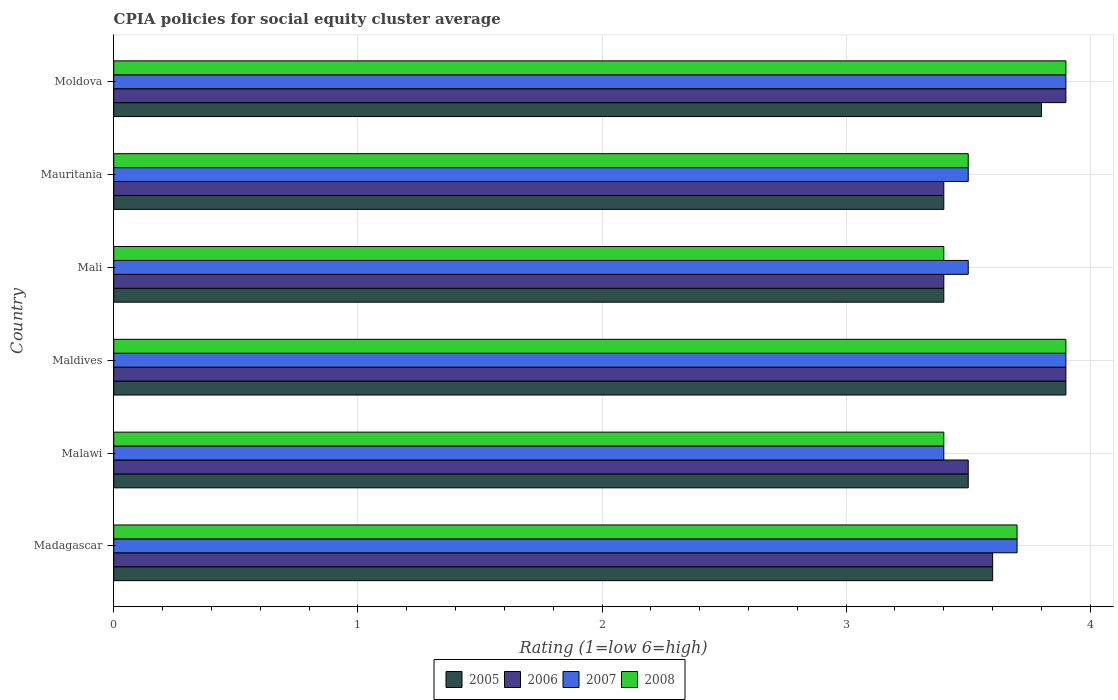How many different coloured bars are there?
Offer a terse response. 4. How many groups of bars are there?
Provide a succinct answer. 6. Are the number of bars on each tick of the Y-axis equal?
Give a very brief answer. Yes. How many bars are there on the 4th tick from the bottom?
Keep it short and to the point. 4. What is the label of the 2nd group of bars from the top?
Offer a terse response. Mauritania. Across all countries, what is the minimum CPIA rating in 2007?
Offer a terse response. 3.4. In which country was the CPIA rating in 2005 maximum?
Your answer should be compact. Maldives. In which country was the CPIA rating in 2006 minimum?
Give a very brief answer. Mali. What is the total CPIA rating in 2007 in the graph?
Provide a short and direct response. 21.9. What is the difference between the CPIA rating in 2008 in Madagascar and that in Mauritania?
Your response must be concise. 0.2. What is the difference between the CPIA rating in 2005 in Moldova and the CPIA rating in 2007 in Maldives?
Your response must be concise. -0.1. What is the average CPIA rating in 2008 per country?
Make the answer very short. 3.63. What is the difference between the CPIA rating in 2005 and CPIA rating in 2007 in Madagascar?
Your answer should be compact. -0.1. What is the ratio of the CPIA rating in 2008 in Madagascar to that in Mali?
Provide a succinct answer. 1.09. Is the difference between the CPIA rating in 2005 in Maldives and Mali greater than the difference between the CPIA rating in 2007 in Maldives and Mali?
Your answer should be compact. Yes. What is the difference between the highest and the second highest CPIA rating in 2008?
Your response must be concise. 0. In how many countries, is the CPIA rating in 2005 greater than the average CPIA rating in 2005 taken over all countries?
Offer a terse response. 2. Is the sum of the CPIA rating in 2005 in Madagascar and Maldives greater than the maximum CPIA rating in 2008 across all countries?
Your answer should be compact. Yes. What does the 1st bar from the bottom in Mali represents?
Provide a short and direct response. 2005. Is it the case that in every country, the sum of the CPIA rating in 2006 and CPIA rating in 2005 is greater than the CPIA rating in 2008?
Your answer should be very brief. Yes. How many bars are there?
Ensure brevity in your answer.  24. How many countries are there in the graph?
Make the answer very short. 6. Does the graph contain grids?
Ensure brevity in your answer.  Yes. How many legend labels are there?
Offer a very short reply. 4. How are the legend labels stacked?
Give a very brief answer. Horizontal. What is the title of the graph?
Ensure brevity in your answer.  CPIA policies for social equity cluster average. What is the Rating (1=low 6=high) of 2007 in Malawi?
Your response must be concise. 3.4. What is the Rating (1=low 6=high) in 2005 in Maldives?
Keep it short and to the point. 3.9. What is the Rating (1=low 6=high) of 2007 in Maldives?
Your answer should be very brief. 3.9. What is the Rating (1=low 6=high) of 2008 in Maldives?
Your response must be concise. 3.9. What is the Rating (1=low 6=high) of 2006 in Mali?
Your answer should be very brief. 3.4. What is the Rating (1=low 6=high) in 2005 in Mauritania?
Provide a succinct answer. 3.4. What is the Rating (1=low 6=high) in 2007 in Mauritania?
Offer a very short reply. 3.5. What is the Rating (1=low 6=high) in 2008 in Mauritania?
Your response must be concise. 3.5. What is the Rating (1=low 6=high) in 2006 in Moldova?
Provide a short and direct response. 3.9. What is the Rating (1=low 6=high) in 2007 in Moldova?
Offer a very short reply. 3.9. Across all countries, what is the maximum Rating (1=low 6=high) of 2007?
Your answer should be compact. 3.9. Across all countries, what is the minimum Rating (1=low 6=high) in 2007?
Make the answer very short. 3.4. Across all countries, what is the minimum Rating (1=low 6=high) of 2008?
Make the answer very short. 3.4. What is the total Rating (1=low 6=high) in 2005 in the graph?
Ensure brevity in your answer.  21.6. What is the total Rating (1=low 6=high) in 2006 in the graph?
Offer a very short reply. 21.7. What is the total Rating (1=low 6=high) of 2007 in the graph?
Your answer should be compact. 21.9. What is the total Rating (1=low 6=high) in 2008 in the graph?
Ensure brevity in your answer.  21.8. What is the difference between the Rating (1=low 6=high) of 2006 in Madagascar and that in Malawi?
Provide a succinct answer. 0.1. What is the difference between the Rating (1=low 6=high) of 2006 in Madagascar and that in Maldives?
Give a very brief answer. -0.3. What is the difference between the Rating (1=low 6=high) of 2007 in Madagascar and that in Maldives?
Provide a succinct answer. -0.2. What is the difference between the Rating (1=low 6=high) in 2005 in Madagascar and that in Mauritania?
Ensure brevity in your answer.  0.2. What is the difference between the Rating (1=low 6=high) in 2007 in Madagascar and that in Mauritania?
Your response must be concise. 0.2. What is the difference between the Rating (1=low 6=high) in 2005 in Madagascar and that in Moldova?
Give a very brief answer. -0.2. What is the difference between the Rating (1=low 6=high) in 2006 in Madagascar and that in Moldova?
Offer a terse response. -0.3. What is the difference between the Rating (1=low 6=high) of 2007 in Madagascar and that in Moldova?
Provide a short and direct response. -0.2. What is the difference between the Rating (1=low 6=high) of 2007 in Malawi and that in Maldives?
Offer a terse response. -0.5. What is the difference between the Rating (1=low 6=high) of 2008 in Malawi and that in Maldives?
Ensure brevity in your answer.  -0.5. What is the difference between the Rating (1=low 6=high) of 2006 in Malawi and that in Moldova?
Your answer should be compact. -0.4. What is the difference between the Rating (1=low 6=high) of 2006 in Maldives and that in Mali?
Provide a short and direct response. 0.5. What is the difference between the Rating (1=low 6=high) of 2005 in Maldives and that in Moldova?
Your answer should be very brief. 0.1. What is the difference between the Rating (1=low 6=high) of 2005 in Mali and that in Mauritania?
Ensure brevity in your answer.  0. What is the difference between the Rating (1=low 6=high) of 2006 in Mali and that in Mauritania?
Provide a short and direct response. 0. What is the difference between the Rating (1=low 6=high) of 2007 in Mali and that in Mauritania?
Give a very brief answer. 0. What is the difference between the Rating (1=low 6=high) of 2008 in Mali and that in Mauritania?
Your answer should be compact. -0.1. What is the difference between the Rating (1=low 6=high) in 2007 in Mali and that in Moldova?
Provide a succinct answer. -0.4. What is the difference between the Rating (1=low 6=high) in 2008 in Mali and that in Moldova?
Provide a succinct answer. -0.5. What is the difference between the Rating (1=low 6=high) in 2006 in Mauritania and that in Moldova?
Provide a short and direct response. -0.5. What is the difference between the Rating (1=low 6=high) of 2007 in Mauritania and that in Moldova?
Your response must be concise. -0.4. What is the difference between the Rating (1=low 6=high) in 2005 in Madagascar and the Rating (1=low 6=high) in 2006 in Malawi?
Offer a terse response. 0.1. What is the difference between the Rating (1=low 6=high) in 2005 in Madagascar and the Rating (1=low 6=high) in 2007 in Malawi?
Make the answer very short. 0.2. What is the difference between the Rating (1=low 6=high) of 2005 in Madagascar and the Rating (1=low 6=high) of 2008 in Malawi?
Give a very brief answer. 0.2. What is the difference between the Rating (1=low 6=high) of 2006 in Madagascar and the Rating (1=low 6=high) of 2007 in Malawi?
Provide a succinct answer. 0.2. What is the difference between the Rating (1=low 6=high) of 2007 in Madagascar and the Rating (1=low 6=high) of 2008 in Malawi?
Offer a very short reply. 0.3. What is the difference between the Rating (1=low 6=high) of 2005 in Madagascar and the Rating (1=low 6=high) of 2008 in Maldives?
Give a very brief answer. -0.3. What is the difference between the Rating (1=low 6=high) of 2006 in Madagascar and the Rating (1=low 6=high) of 2007 in Maldives?
Your answer should be compact. -0.3. What is the difference between the Rating (1=low 6=high) in 2005 in Madagascar and the Rating (1=low 6=high) in 2006 in Mali?
Your response must be concise. 0.2. What is the difference between the Rating (1=low 6=high) of 2005 in Madagascar and the Rating (1=low 6=high) of 2008 in Mali?
Your answer should be very brief. 0.2. What is the difference between the Rating (1=low 6=high) in 2006 in Madagascar and the Rating (1=low 6=high) in 2008 in Mali?
Offer a terse response. 0.2. What is the difference between the Rating (1=low 6=high) in 2006 in Madagascar and the Rating (1=low 6=high) in 2007 in Mauritania?
Provide a short and direct response. 0.1. What is the difference between the Rating (1=low 6=high) of 2006 in Madagascar and the Rating (1=low 6=high) of 2008 in Mauritania?
Your answer should be compact. 0.1. What is the difference between the Rating (1=low 6=high) of 2007 in Madagascar and the Rating (1=low 6=high) of 2008 in Mauritania?
Provide a short and direct response. 0.2. What is the difference between the Rating (1=low 6=high) of 2005 in Madagascar and the Rating (1=low 6=high) of 2007 in Moldova?
Keep it short and to the point. -0.3. What is the difference between the Rating (1=low 6=high) of 2006 in Madagascar and the Rating (1=low 6=high) of 2007 in Moldova?
Your answer should be very brief. -0.3. What is the difference between the Rating (1=low 6=high) in 2005 in Malawi and the Rating (1=low 6=high) in 2006 in Maldives?
Your response must be concise. -0.4. What is the difference between the Rating (1=low 6=high) of 2006 in Malawi and the Rating (1=low 6=high) of 2008 in Maldives?
Give a very brief answer. -0.4. What is the difference between the Rating (1=low 6=high) in 2005 in Malawi and the Rating (1=low 6=high) in 2007 in Mali?
Your response must be concise. 0. What is the difference between the Rating (1=low 6=high) of 2005 in Malawi and the Rating (1=low 6=high) of 2008 in Mali?
Keep it short and to the point. 0.1. What is the difference between the Rating (1=low 6=high) of 2006 in Malawi and the Rating (1=low 6=high) of 2008 in Mali?
Provide a short and direct response. 0.1. What is the difference between the Rating (1=low 6=high) in 2005 in Malawi and the Rating (1=low 6=high) in 2006 in Mauritania?
Ensure brevity in your answer.  0.1. What is the difference between the Rating (1=low 6=high) in 2005 in Malawi and the Rating (1=low 6=high) in 2007 in Mauritania?
Make the answer very short. 0. What is the difference between the Rating (1=low 6=high) in 2006 in Malawi and the Rating (1=low 6=high) in 2007 in Mauritania?
Your response must be concise. 0. What is the difference between the Rating (1=low 6=high) in 2005 in Malawi and the Rating (1=low 6=high) in 2007 in Moldova?
Your answer should be compact. -0.4. What is the difference between the Rating (1=low 6=high) of 2007 in Malawi and the Rating (1=low 6=high) of 2008 in Moldova?
Provide a short and direct response. -0.5. What is the difference between the Rating (1=low 6=high) in 2005 in Maldives and the Rating (1=low 6=high) in 2007 in Mali?
Your answer should be very brief. 0.4. What is the difference between the Rating (1=low 6=high) of 2005 in Maldives and the Rating (1=low 6=high) of 2008 in Mali?
Keep it short and to the point. 0.5. What is the difference between the Rating (1=low 6=high) of 2006 in Maldives and the Rating (1=low 6=high) of 2007 in Mali?
Provide a succinct answer. 0.4. What is the difference between the Rating (1=low 6=high) in 2006 in Maldives and the Rating (1=low 6=high) in 2008 in Mali?
Your answer should be very brief. 0.5. What is the difference between the Rating (1=low 6=high) in 2007 in Maldives and the Rating (1=low 6=high) in 2008 in Mali?
Provide a short and direct response. 0.5. What is the difference between the Rating (1=low 6=high) in 2005 in Maldives and the Rating (1=low 6=high) in 2006 in Moldova?
Offer a terse response. 0. What is the difference between the Rating (1=low 6=high) of 2006 in Maldives and the Rating (1=low 6=high) of 2007 in Moldova?
Your response must be concise. 0. What is the difference between the Rating (1=low 6=high) in 2007 in Maldives and the Rating (1=low 6=high) in 2008 in Moldova?
Your answer should be compact. 0. What is the difference between the Rating (1=low 6=high) in 2005 in Mali and the Rating (1=low 6=high) in 2006 in Mauritania?
Offer a terse response. 0. What is the difference between the Rating (1=low 6=high) in 2005 in Mali and the Rating (1=low 6=high) in 2007 in Mauritania?
Ensure brevity in your answer.  -0.1. What is the difference between the Rating (1=low 6=high) in 2006 in Mali and the Rating (1=low 6=high) in 2008 in Mauritania?
Offer a very short reply. -0.1. What is the difference between the Rating (1=low 6=high) of 2007 in Mali and the Rating (1=low 6=high) of 2008 in Mauritania?
Ensure brevity in your answer.  0. What is the difference between the Rating (1=low 6=high) of 2005 in Mali and the Rating (1=low 6=high) of 2006 in Moldova?
Offer a very short reply. -0.5. What is the difference between the Rating (1=low 6=high) in 2005 in Mali and the Rating (1=low 6=high) in 2008 in Moldova?
Keep it short and to the point. -0.5. What is the difference between the Rating (1=low 6=high) in 2006 in Mali and the Rating (1=low 6=high) in 2007 in Moldova?
Provide a succinct answer. -0.5. What is the difference between the Rating (1=low 6=high) in 2006 in Mali and the Rating (1=low 6=high) in 2008 in Moldova?
Your answer should be compact. -0.5. What is the difference between the Rating (1=low 6=high) of 2005 in Mauritania and the Rating (1=low 6=high) of 2007 in Moldova?
Offer a terse response. -0.5. What is the difference between the Rating (1=low 6=high) in 2005 in Mauritania and the Rating (1=low 6=high) in 2008 in Moldova?
Your answer should be very brief. -0.5. What is the difference between the Rating (1=low 6=high) of 2006 in Mauritania and the Rating (1=low 6=high) of 2007 in Moldova?
Your answer should be compact. -0.5. What is the average Rating (1=low 6=high) in 2006 per country?
Give a very brief answer. 3.62. What is the average Rating (1=low 6=high) in 2007 per country?
Provide a short and direct response. 3.65. What is the average Rating (1=low 6=high) of 2008 per country?
Your answer should be compact. 3.63. What is the difference between the Rating (1=low 6=high) of 2005 and Rating (1=low 6=high) of 2008 in Madagascar?
Your answer should be very brief. -0.1. What is the difference between the Rating (1=low 6=high) of 2006 and Rating (1=low 6=high) of 2008 in Madagascar?
Provide a succinct answer. -0.1. What is the difference between the Rating (1=low 6=high) in 2005 and Rating (1=low 6=high) in 2007 in Malawi?
Your answer should be compact. 0.1. What is the difference between the Rating (1=low 6=high) of 2006 and Rating (1=low 6=high) of 2007 in Maldives?
Provide a succinct answer. 0. What is the difference between the Rating (1=low 6=high) of 2006 and Rating (1=low 6=high) of 2008 in Maldives?
Provide a succinct answer. 0. What is the difference between the Rating (1=low 6=high) of 2005 and Rating (1=low 6=high) of 2006 in Mali?
Give a very brief answer. 0. What is the difference between the Rating (1=low 6=high) in 2005 and Rating (1=low 6=high) in 2007 in Mali?
Give a very brief answer. -0.1. What is the difference between the Rating (1=low 6=high) in 2007 and Rating (1=low 6=high) in 2008 in Mali?
Make the answer very short. 0.1. What is the difference between the Rating (1=low 6=high) in 2005 and Rating (1=low 6=high) in 2006 in Mauritania?
Give a very brief answer. 0. What is the difference between the Rating (1=low 6=high) in 2005 and Rating (1=low 6=high) in 2007 in Mauritania?
Your answer should be very brief. -0.1. What is the difference between the Rating (1=low 6=high) in 2005 and Rating (1=low 6=high) in 2008 in Mauritania?
Keep it short and to the point. -0.1. What is the difference between the Rating (1=low 6=high) in 2006 and Rating (1=low 6=high) in 2007 in Mauritania?
Your answer should be very brief. -0.1. What is the difference between the Rating (1=low 6=high) in 2007 and Rating (1=low 6=high) in 2008 in Mauritania?
Make the answer very short. 0. What is the difference between the Rating (1=low 6=high) in 2005 and Rating (1=low 6=high) in 2006 in Moldova?
Keep it short and to the point. -0.1. What is the difference between the Rating (1=low 6=high) in 2006 and Rating (1=low 6=high) in 2008 in Moldova?
Provide a short and direct response. 0. What is the difference between the Rating (1=low 6=high) of 2007 and Rating (1=low 6=high) of 2008 in Moldova?
Keep it short and to the point. 0. What is the ratio of the Rating (1=low 6=high) of 2005 in Madagascar to that in Malawi?
Provide a succinct answer. 1.03. What is the ratio of the Rating (1=low 6=high) in 2006 in Madagascar to that in Malawi?
Offer a very short reply. 1.03. What is the ratio of the Rating (1=low 6=high) in 2007 in Madagascar to that in Malawi?
Your answer should be very brief. 1.09. What is the ratio of the Rating (1=low 6=high) in 2008 in Madagascar to that in Malawi?
Offer a terse response. 1.09. What is the ratio of the Rating (1=low 6=high) in 2005 in Madagascar to that in Maldives?
Your answer should be very brief. 0.92. What is the ratio of the Rating (1=low 6=high) of 2007 in Madagascar to that in Maldives?
Ensure brevity in your answer.  0.95. What is the ratio of the Rating (1=low 6=high) of 2008 in Madagascar to that in Maldives?
Give a very brief answer. 0.95. What is the ratio of the Rating (1=low 6=high) in 2005 in Madagascar to that in Mali?
Provide a succinct answer. 1.06. What is the ratio of the Rating (1=low 6=high) of 2006 in Madagascar to that in Mali?
Your answer should be very brief. 1.06. What is the ratio of the Rating (1=low 6=high) of 2007 in Madagascar to that in Mali?
Your answer should be very brief. 1.06. What is the ratio of the Rating (1=low 6=high) in 2008 in Madagascar to that in Mali?
Your answer should be compact. 1.09. What is the ratio of the Rating (1=low 6=high) of 2005 in Madagascar to that in Mauritania?
Your answer should be very brief. 1.06. What is the ratio of the Rating (1=low 6=high) of 2006 in Madagascar to that in Mauritania?
Provide a short and direct response. 1.06. What is the ratio of the Rating (1=low 6=high) in 2007 in Madagascar to that in Mauritania?
Offer a terse response. 1.06. What is the ratio of the Rating (1=low 6=high) of 2008 in Madagascar to that in Mauritania?
Give a very brief answer. 1.06. What is the ratio of the Rating (1=low 6=high) in 2007 in Madagascar to that in Moldova?
Your answer should be very brief. 0.95. What is the ratio of the Rating (1=low 6=high) in 2008 in Madagascar to that in Moldova?
Your answer should be very brief. 0.95. What is the ratio of the Rating (1=low 6=high) of 2005 in Malawi to that in Maldives?
Provide a succinct answer. 0.9. What is the ratio of the Rating (1=low 6=high) in 2006 in Malawi to that in Maldives?
Ensure brevity in your answer.  0.9. What is the ratio of the Rating (1=low 6=high) in 2007 in Malawi to that in Maldives?
Provide a succinct answer. 0.87. What is the ratio of the Rating (1=low 6=high) in 2008 in Malawi to that in Maldives?
Your answer should be compact. 0.87. What is the ratio of the Rating (1=low 6=high) in 2005 in Malawi to that in Mali?
Your answer should be compact. 1.03. What is the ratio of the Rating (1=low 6=high) in 2006 in Malawi to that in Mali?
Provide a succinct answer. 1.03. What is the ratio of the Rating (1=low 6=high) in 2007 in Malawi to that in Mali?
Offer a very short reply. 0.97. What is the ratio of the Rating (1=low 6=high) of 2005 in Malawi to that in Mauritania?
Provide a short and direct response. 1.03. What is the ratio of the Rating (1=low 6=high) of 2006 in Malawi to that in Mauritania?
Offer a terse response. 1.03. What is the ratio of the Rating (1=low 6=high) of 2007 in Malawi to that in Mauritania?
Ensure brevity in your answer.  0.97. What is the ratio of the Rating (1=low 6=high) of 2008 in Malawi to that in Mauritania?
Your response must be concise. 0.97. What is the ratio of the Rating (1=low 6=high) of 2005 in Malawi to that in Moldova?
Ensure brevity in your answer.  0.92. What is the ratio of the Rating (1=low 6=high) in 2006 in Malawi to that in Moldova?
Offer a very short reply. 0.9. What is the ratio of the Rating (1=low 6=high) of 2007 in Malawi to that in Moldova?
Keep it short and to the point. 0.87. What is the ratio of the Rating (1=low 6=high) in 2008 in Malawi to that in Moldova?
Ensure brevity in your answer.  0.87. What is the ratio of the Rating (1=low 6=high) in 2005 in Maldives to that in Mali?
Ensure brevity in your answer.  1.15. What is the ratio of the Rating (1=low 6=high) in 2006 in Maldives to that in Mali?
Ensure brevity in your answer.  1.15. What is the ratio of the Rating (1=low 6=high) of 2007 in Maldives to that in Mali?
Make the answer very short. 1.11. What is the ratio of the Rating (1=low 6=high) of 2008 in Maldives to that in Mali?
Offer a terse response. 1.15. What is the ratio of the Rating (1=low 6=high) in 2005 in Maldives to that in Mauritania?
Keep it short and to the point. 1.15. What is the ratio of the Rating (1=low 6=high) of 2006 in Maldives to that in Mauritania?
Offer a terse response. 1.15. What is the ratio of the Rating (1=low 6=high) in 2007 in Maldives to that in Mauritania?
Your answer should be compact. 1.11. What is the ratio of the Rating (1=low 6=high) in 2008 in Maldives to that in Mauritania?
Offer a very short reply. 1.11. What is the ratio of the Rating (1=low 6=high) in 2005 in Maldives to that in Moldova?
Offer a very short reply. 1.03. What is the ratio of the Rating (1=low 6=high) in 2008 in Mali to that in Mauritania?
Make the answer very short. 0.97. What is the ratio of the Rating (1=low 6=high) in 2005 in Mali to that in Moldova?
Keep it short and to the point. 0.89. What is the ratio of the Rating (1=low 6=high) in 2006 in Mali to that in Moldova?
Offer a very short reply. 0.87. What is the ratio of the Rating (1=low 6=high) of 2007 in Mali to that in Moldova?
Provide a short and direct response. 0.9. What is the ratio of the Rating (1=low 6=high) in 2008 in Mali to that in Moldova?
Make the answer very short. 0.87. What is the ratio of the Rating (1=low 6=high) of 2005 in Mauritania to that in Moldova?
Keep it short and to the point. 0.89. What is the ratio of the Rating (1=low 6=high) in 2006 in Mauritania to that in Moldova?
Your answer should be compact. 0.87. What is the ratio of the Rating (1=low 6=high) of 2007 in Mauritania to that in Moldova?
Your answer should be compact. 0.9. What is the ratio of the Rating (1=low 6=high) in 2008 in Mauritania to that in Moldova?
Your answer should be compact. 0.9. What is the difference between the highest and the second highest Rating (1=low 6=high) of 2005?
Give a very brief answer. 0.1. What is the difference between the highest and the second highest Rating (1=low 6=high) in 2008?
Your response must be concise. 0. What is the difference between the highest and the lowest Rating (1=low 6=high) in 2006?
Provide a short and direct response. 0.5. What is the difference between the highest and the lowest Rating (1=low 6=high) in 2007?
Offer a very short reply. 0.5. 